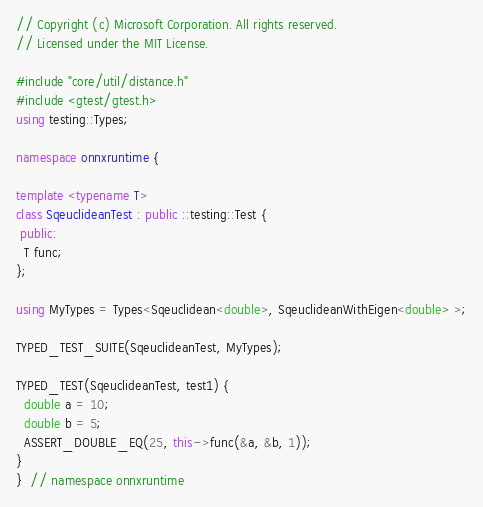Convert code to text. <code><loc_0><loc_0><loc_500><loc_500><_C++_>// Copyright (c) Microsoft Corporation. All rights reserved.
// Licensed under the MIT License.

#include "core/util/distance.h"
#include <gtest/gtest.h>
using testing::Types;

namespace onnxruntime {

template <typename T>
class SqeuclideanTest : public ::testing::Test {
 public:
  T func;
};

using MyTypes = Types<Sqeuclidean<double>, SqeuclideanWithEigen<double> >;

TYPED_TEST_SUITE(SqeuclideanTest, MyTypes);

TYPED_TEST(SqeuclideanTest, test1) {
  double a = 10;
  double b = 5;
  ASSERT_DOUBLE_EQ(25, this->func(&a, &b, 1));
}
}  // namespace onnxruntime</code> 